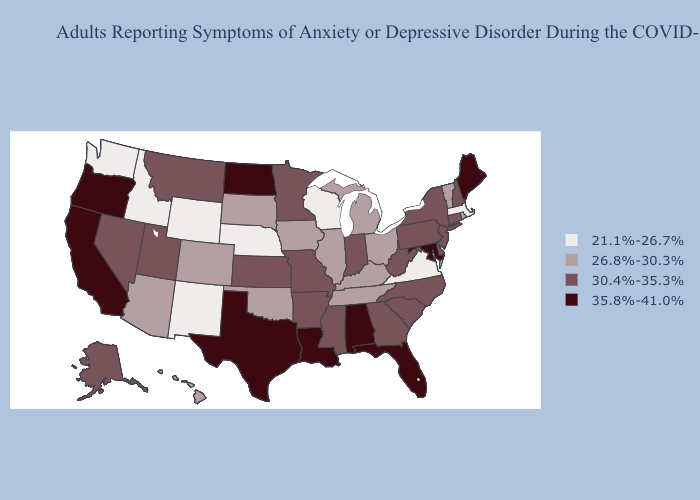Which states have the lowest value in the South?
Answer briefly. Virginia. What is the highest value in the South ?
Concise answer only. 35.8%-41.0%. Does Tennessee have a lower value than South Dakota?
Keep it brief. No. What is the value of Kansas?
Quick response, please. 30.4%-35.3%. What is the value of Mississippi?
Answer briefly. 30.4%-35.3%. Name the states that have a value in the range 35.8%-41.0%?
Short answer required. Alabama, California, Florida, Louisiana, Maine, Maryland, North Dakota, Oregon, Texas. Does Utah have the lowest value in the West?
Answer briefly. No. What is the value of Montana?
Short answer required. 30.4%-35.3%. Does Nevada have a lower value than Alabama?
Keep it brief. Yes. What is the lowest value in states that border Tennessee?
Answer briefly. 21.1%-26.7%. Does California have a higher value than West Virginia?
Concise answer only. Yes. Does Maryland have the lowest value in the USA?
Write a very short answer. No. What is the value of Mississippi?
Keep it brief. 30.4%-35.3%. What is the value of Missouri?
Answer briefly. 30.4%-35.3%. What is the highest value in states that border New York?
Keep it brief. 30.4%-35.3%. 